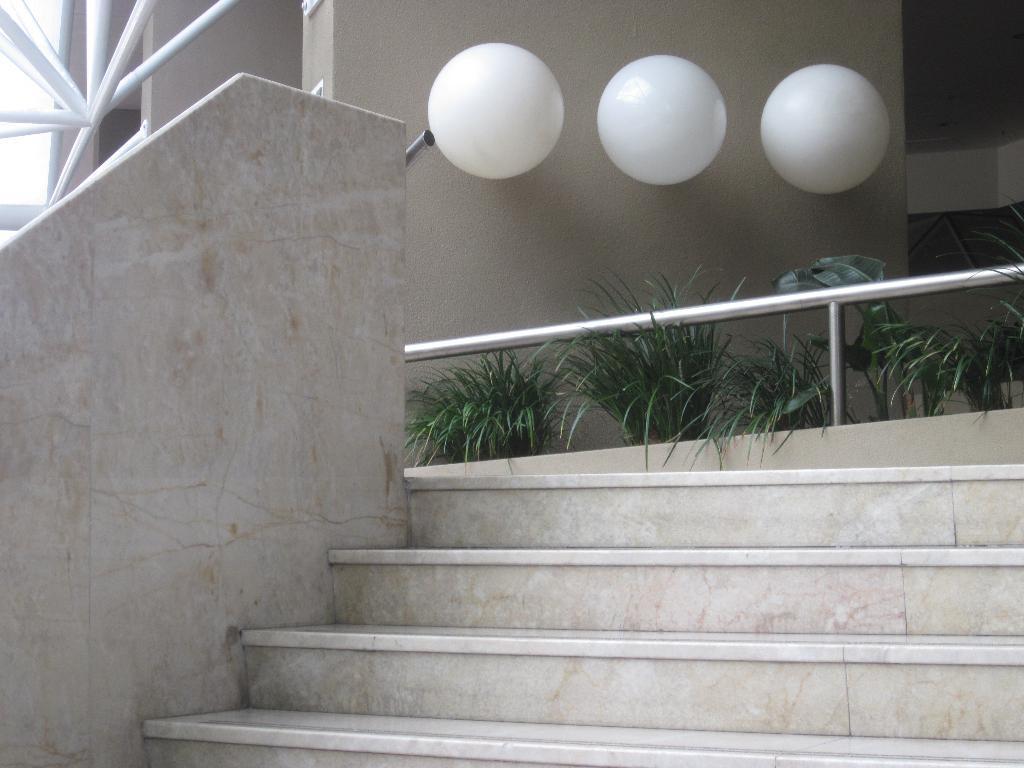Describe this image in one or two sentences. These are the staircases and here there are plants and these are the white color balls on the wall. 